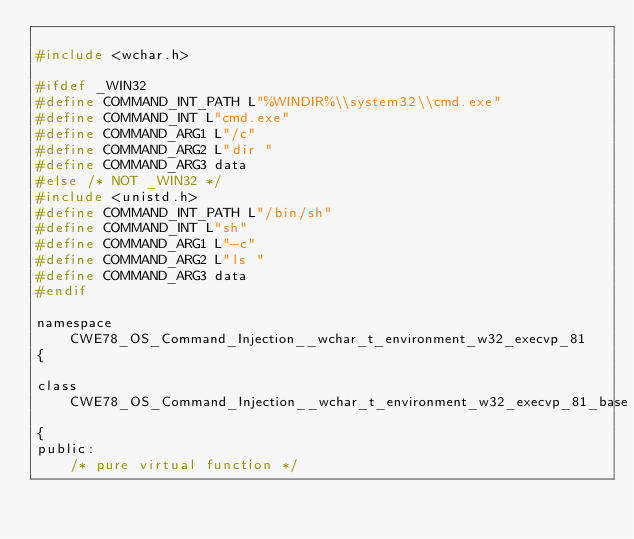<code> <loc_0><loc_0><loc_500><loc_500><_C_>
#include <wchar.h>

#ifdef _WIN32
#define COMMAND_INT_PATH L"%WINDIR%\\system32\\cmd.exe"
#define COMMAND_INT L"cmd.exe"
#define COMMAND_ARG1 L"/c"
#define COMMAND_ARG2 L"dir "
#define COMMAND_ARG3 data
#else /* NOT _WIN32 */
#include <unistd.h>
#define COMMAND_INT_PATH L"/bin/sh"
#define COMMAND_INT L"sh"
#define COMMAND_ARG1 L"-c"
#define COMMAND_ARG2 L"ls "
#define COMMAND_ARG3 data
#endif

namespace CWE78_OS_Command_Injection__wchar_t_environment_w32_execvp_81
{

class CWE78_OS_Command_Injection__wchar_t_environment_w32_execvp_81_base
{
public:
    /* pure virtual function */</code> 